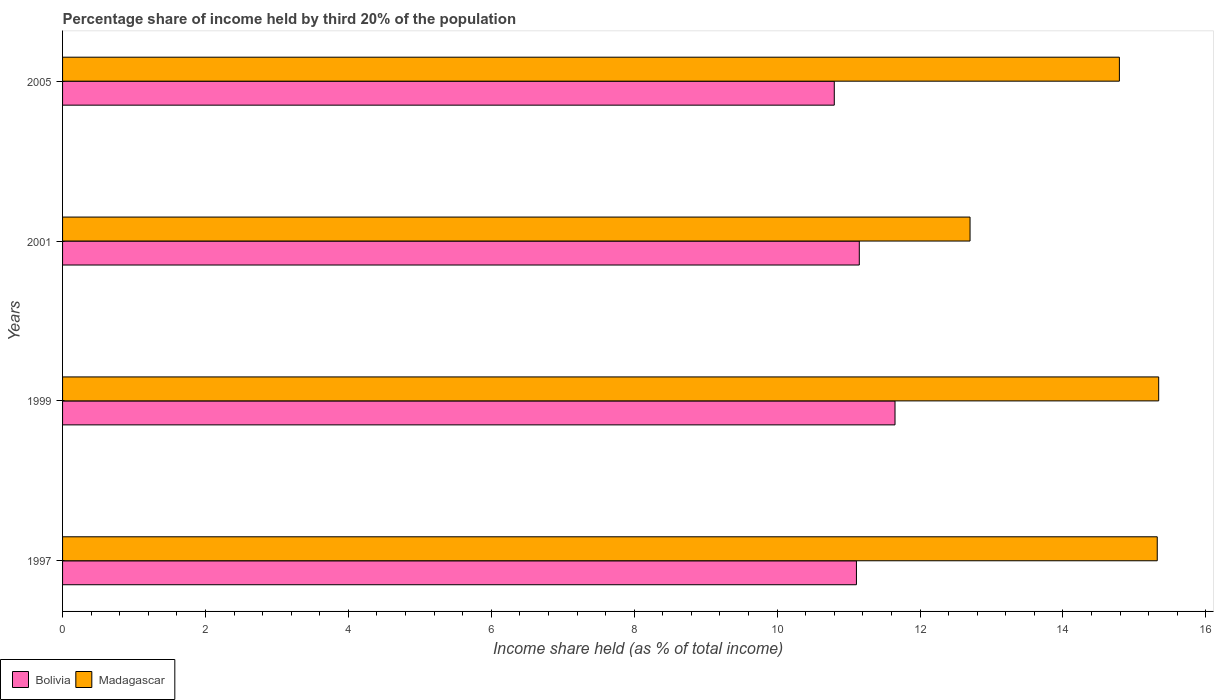How many different coloured bars are there?
Your answer should be compact. 2. How many bars are there on the 3rd tick from the bottom?
Offer a very short reply. 2. What is the label of the 2nd group of bars from the top?
Offer a very short reply. 2001. In how many cases, is the number of bars for a given year not equal to the number of legend labels?
Ensure brevity in your answer.  0. What is the share of income held by third 20% of the population in Madagascar in 2005?
Provide a succinct answer. 14.79. Across all years, what is the maximum share of income held by third 20% of the population in Madagascar?
Provide a short and direct response. 15.34. What is the total share of income held by third 20% of the population in Madagascar in the graph?
Make the answer very short. 58.15. What is the difference between the share of income held by third 20% of the population in Bolivia in 1997 and that in 1999?
Offer a terse response. -0.54. What is the difference between the share of income held by third 20% of the population in Bolivia in 1997 and the share of income held by third 20% of the population in Madagascar in 2001?
Your answer should be compact. -1.59. What is the average share of income held by third 20% of the population in Bolivia per year?
Offer a terse response. 11.18. In the year 1999, what is the difference between the share of income held by third 20% of the population in Madagascar and share of income held by third 20% of the population in Bolivia?
Give a very brief answer. 3.69. In how many years, is the share of income held by third 20% of the population in Bolivia greater than 14.8 %?
Provide a succinct answer. 0. What is the ratio of the share of income held by third 20% of the population in Madagascar in 1999 to that in 2005?
Your answer should be compact. 1.04. Is the difference between the share of income held by third 20% of the population in Madagascar in 1999 and 2005 greater than the difference between the share of income held by third 20% of the population in Bolivia in 1999 and 2005?
Your answer should be very brief. No. What is the difference between the highest and the lowest share of income held by third 20% of the population in Madagascar?
Offer a very short reply. 2.64. What does the 1st bar from the top in 1999 represents?
Your answer should be very brief. Madagascar. What does the 1st bar from the bottom in 2001 represents?
Keep it short and to the point. Bolivia. How many bars are there?
Give a very brief answer. 8. How many years are there in the graph?
Your answer should be very brief. 4. What is the difference between two consecutive major ticks on the X-axis?
Your answer should be compact. 2. Are the values on the major ticks of X-axis written in scientific E-notation?
Ensure brevity in your answer.  No. How are the legend labels stacked?
Keep it short and to the point. Horizontal. What is the title of the graph?
Provide a short and direct response. Percentage share of income held by third 20% of the population. Does "Latin America(all income levels)" appear as one of the legend labels in the graph?
Ensure brevity in your answer.  No. What is the label or title of the X-axis?
Offer a very short reply. Income share held (as % of total income). What is the Income share held (as % of total income) of Bolivia in 1997?
Your answer should be very brief. 11.11. What is the Income share held (as % of total income) of Madagascar in 1997?
Provide a succinct answer. 15.32. What is the Income share held (as % of total income) in Bolivia in 1999?
Offer a terse response. 11.65. What is the Income share held (as % of total income) in Madagascar in 1999?
Provide a short and direct response. 15.34. What is the Income share held (as % of total income) of Bolivia in 2001?
Offer a very short reply. 11.15. What is the Income share held (as % of total income) in Bolivia in 2005?
Offer a very short reply. 10.8. What is the Income share held (as % of total income) in Madagascar in 2005?
Your response must be concise. 14.79. Across all years, what is the maximum Income share held (as % of total income) of Bolivia?
Your answer should be compact. 11.65. Across all years, what is the maximum Income share held (as % of total income) in Madagascar?
Give a very brief answer. 15.34. Across all years, what is the minimum Income share held (as % of total income) in Bolivia?
Provide a short and direct response. 10.8. What is the total Income share held (as % of total income) in Bolivia in the graph?
Make the answer very short. 44.71. What is the total Income share held (as % of total income) of Madagascar in the graph?
Ensure brevity in your answer.  58.15. What is the difference between the Income share held (as % of total income) of Bolivia in 1997 and that in 1999?
Offer a terse response. -0.54. What is the difference between the Income share held (as % of total income) in Madagascar in 1997 and that in 1999?
Give a very brief answer. -0.02. What is the difference between the Income share held (as % of total income) of Bolivia in 1997 and that in 2001?
Make the answer very short. -0.04. What is the difference between the Income share held (as % of total income) of Madagascar in 1997 and that in 2001?
Your answer should be very brief. 2.62. What is the difference between the Income share held (as % of total income) in Bolivia in 1997 and that in 2005?
Provide a succinct answer. 0.31. What is the difference between the Income share held (as % of total income) in Madagascar in 1997 and that in 2005?
Provide a short and direct response. 0.53. What is the difference between the Income share held (as % of total income) of Madagascar in 1999 and that in 2001?
Offer a terse response. 2.64. What is the difference between the Income share held (as % of total income) of Bolivia in 1999 and that in 2005?
Your answer should be compact. 0.85. What is the difference between the Income share held (as % of total income) in Madagascar in 1999 and that in 2005?
Your answer should be very brief. 0.55. What is the difference between the Income share held (as % of total income) in Madagascar in 2001 and that in 2005?
Your answer should be very brief. -2.09. What is the difference between the Income share held (as % of total income) of Bolivia in 1997 and the Income share held (as % of total income) of Madagascar in 1999?
Make the answer very short. -4.23. What is the difference between the Income share held (as % of total income) of Bolivia in 1997 and the Income share held (as % of total income) of Madagascar in 2001?
Offer a terse response. -1.59. What is the difference between the Income share held (as % of total income) of Bolivia in 1997 and the Income share held (as % of total income) of Madagascar in 2005?
Provide a short and direct response. -3.68. What is the difference between the Income share held (as % of total income) in Bolivia in 1999 and the Income share held (as % of total income) in Madagascar in 2001?
Provide a succinct answer. -1.05. What is the difference between the Income share held (as % of total income) of Bolivia in 1999 and the Income share held (as % of total income) of Madagascar in 2005?
Your response must be concise. -3.14. What is the difference between the Income share held (as % of total income) of Bolivia in 2001 and the Income share held (as % of total income) of Madagascar in 2005?
Offer a very short reply. -3.64. What is the average Income share held (as % of total income) in Bolivia per year?
Offer a very short reply. 11.18. What is the average Income share held (as % of total income) of Madagascar per year?
Your answer should be very brief. 14.54. In the year 1997, what is the difference between the Income share held (as % of total income) in Bolivia and Income share held (as % of total income) in Madagascar?
Ensure brevity in your answer.  -4.21. In the year 1999, what is the difference between the Income share held (as % of total income) of Bolivia and Income share held (as % of total income) of Madagascar?
Give a very brief answer. -3.69. In the year 2001, what is the difference between the Income share held (as % of total income) of Bolivia and Income share held (as % of total income) of Madagascar?
Your answer should be very brief. -1.55. In the year 2005, what is the difference between the Income share held (as % of total income) in Bolivia and Income share held (as % of total income) in Madagascar?
Keep it short and to the point. -3.99. What is the ratio of the Income share held (as % of total income) in Bolivia in 1997 to that in 1999?
Make the answer very short. 0.95. What is the ratio of the Income share held (as % of total income) in Bolivia in 1997 to that in 2001?
Offer a terse response. 1. What is the ratio of the Income share held (as % of total income) of Madagascar in 1997 to that in 2001?
Ensure brevity in your answer.  1.21. What is the ratio of the Income share held (as % of total income) in Bolivia in 1997 to that in 2005?
Offer a terse response. 1.03. What is the ratio of the Income share held (as % of total income) of Madagascar in 1997 to that in 2005?
Make the answer very short. 1.04. What is the ratio of the Income share held (as % of total income) in Bolivia in 1999 to that in 2001?
Your response must be concise. 1.04. What is the ratio of the Income share held (as % of total income) of Madagascar in 1999 to that in 2001?
Give a very brief answer. 1.21. What is the ratio of the Income share held (as % of total income) of Bolivia in 1999 to that in 2005?
Give a very brief answer. 1.08. What is the ratio of the Income share held (as % of total income) of Madagascar in 1999 to that in 2005?
Make the answer very short. 1.04. What is the ratio of the Income share held (as % of total income) in Bolivia in 2001 to that in 2005?
Make the answer very short. 1.03. What is the ratio of the Income share held (as % of total income) of Madagascar in 2001 to that in 2005?
Provide a short and direct response. 0.86. What is the difference between the highest and the second highest Income share held (as % of total income) of Bolivia?
Your answer should be compact. 0.5. What is the difference between the highest and the lowest Income share held (as % of total income) in Bolivia?
Keep it short and to the point. 0.85. What is the difference between the highest and the lowest Income share held (as % of total income) of Madagascar?
Your response must be concise. 2.64. 